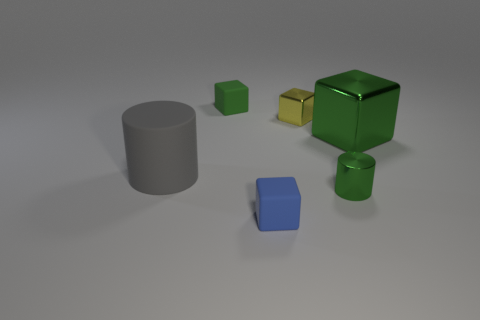Are there any other things that have the same size as the matte cylinder?
Provide a short and direct response. Yes. Are there fewer large gray matte objects that are in front of the small green cylinder than large brown balls?
Your answer should be compact. No. Do the tiny green thing that is behind the gray cylinder and the yellow object have the same material?
Your answer should be compact. No. What shape is the small object that is left of the tiny rubber block that is in front of the tiny rubber cube behind the yellow object?
Provide a short and direct response. Cube. Are there any gray rubber objects of the same size as the gray rubber cylinder?
Ensure brevity in your answer.  No. What is the size of the matte cylinder?
Offer a very short reply. Large. What number of gray cylinders have the same size as the green shiny block?
Offer a very short reply. 1. Is the number of small cylinders that are on the right side of the tiny green metal object less than the number of yellow things that are in front of the green metal cube?
Offer a very short reply. No. There is a cylinder on the left side of the tiny object that is to the left of the tiny matte thing in front of the small green cube; how big is it?
Your answer should be compact. Large. What is the size of the thing that is right of the small green rubber object and behind the large green thing?
Provide a short and direct response. Small. 